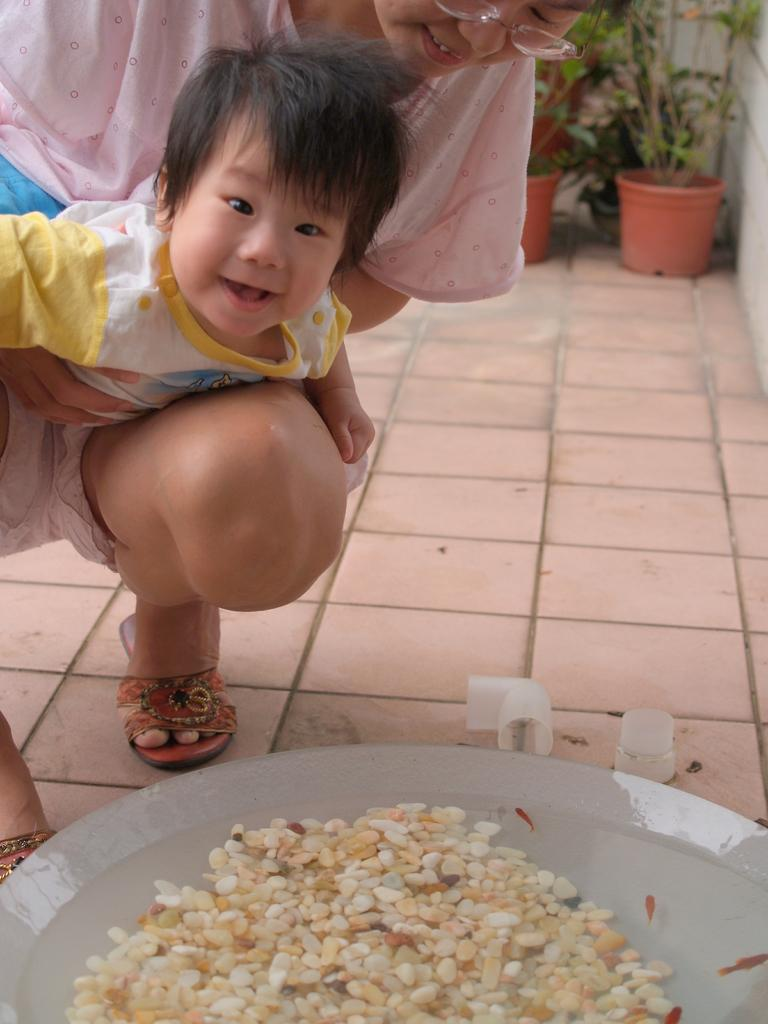Who is the main subject in the image? There is a woman in the image. What is the woman doing in the image? The woman is holding a baby. What else can be seen in the image besides the woman and baby? There are objects in front of the woman and baby. Where are the plant pots located in the image? The plant pots are in the right top corner of the image. What type of turkey can be seen in the image? There is no turkey present in the image. Is the woman in the image a farmer? The image does not provide any information about the woman's occupation, so it cannot be determined if she is a farmer. 